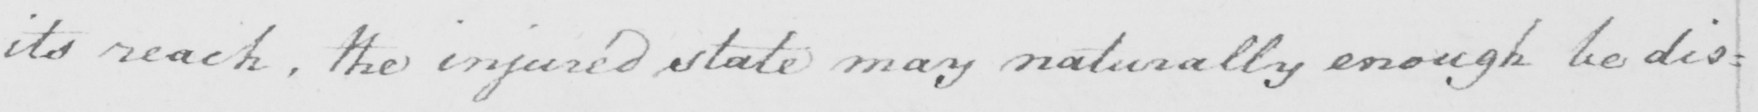What is written in this line of handwriting? its reach, the injured state may naturally enough be dis= 